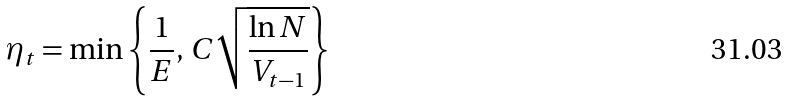<formula> <loc_0><loc_0><loc_500><loc_500>\eta _ { t } = \min \left \{ \frac { 1 } { E } , \, C \sqrt { \frac { \ln N } { V _ { t - 1 } } } \right \}</formula> 